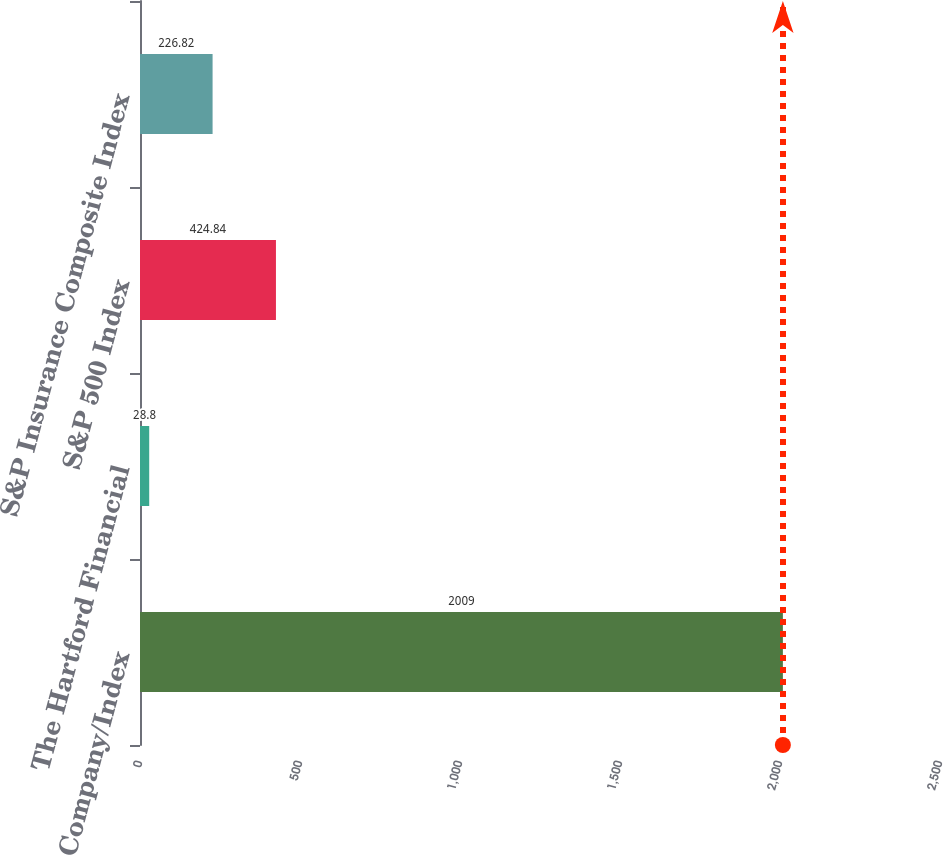Convert chart to OTSL. <chart><loc_0><loc_0><loc_500><loc_500><bar_chart><fcel>Company/Index<fcel>The Hartford Financial<fcel>S&P 500 Index<fcel>S&P Insurance Composite Index<nl><fcel>2009<fcel>28.8<fcel>424.84<fcel>226.82<nl></chart> 